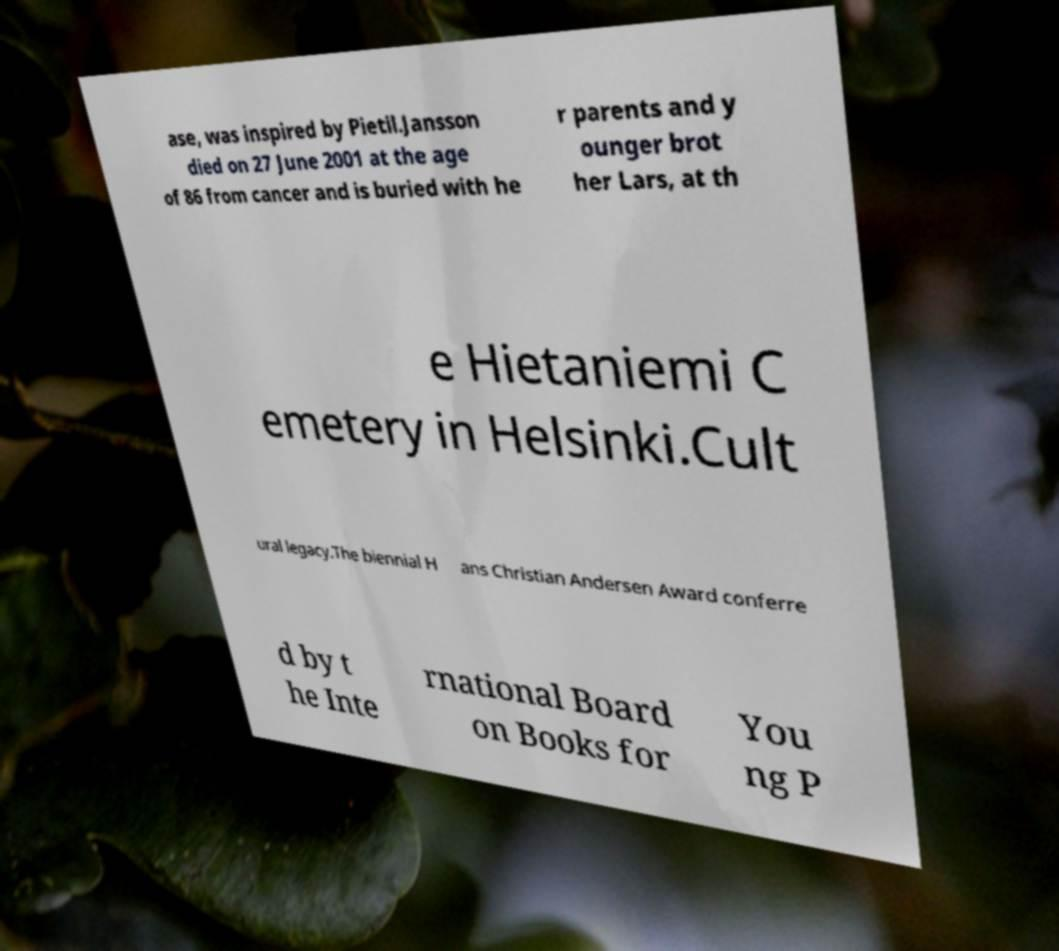Can you accurately transcribe the text from the provided image for me? ase, was inspired by Pietil.Jansson died on 27 June 2001 at the age of 86 from cancer and is buried with he r parents and y ounger brot her Lars, at th e Hietaniemi C emetery in Helsinki.Cult ural legacy.The biennial H ans Christian Andersen Award conferre d by t he Inte rnational Board on Books for You ng P 